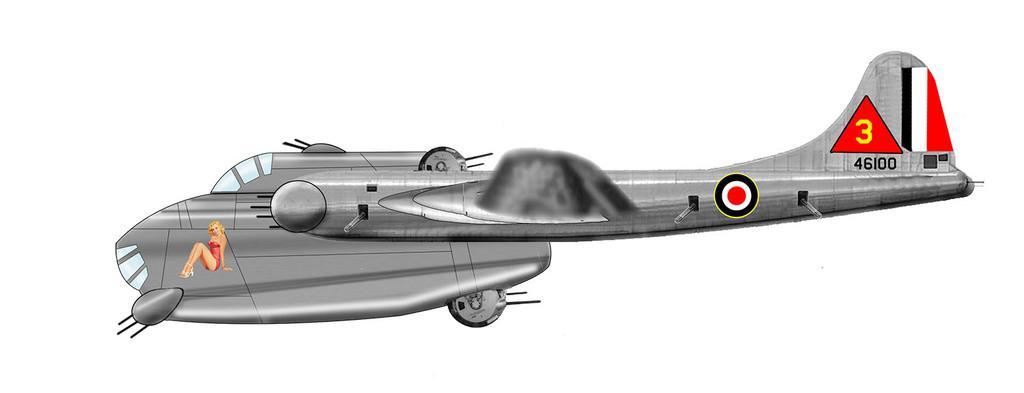Describe this image in one or two sentences. In the picture there is an animated image of plane and on the plane there is a picture of a woman in a sitting poster. 